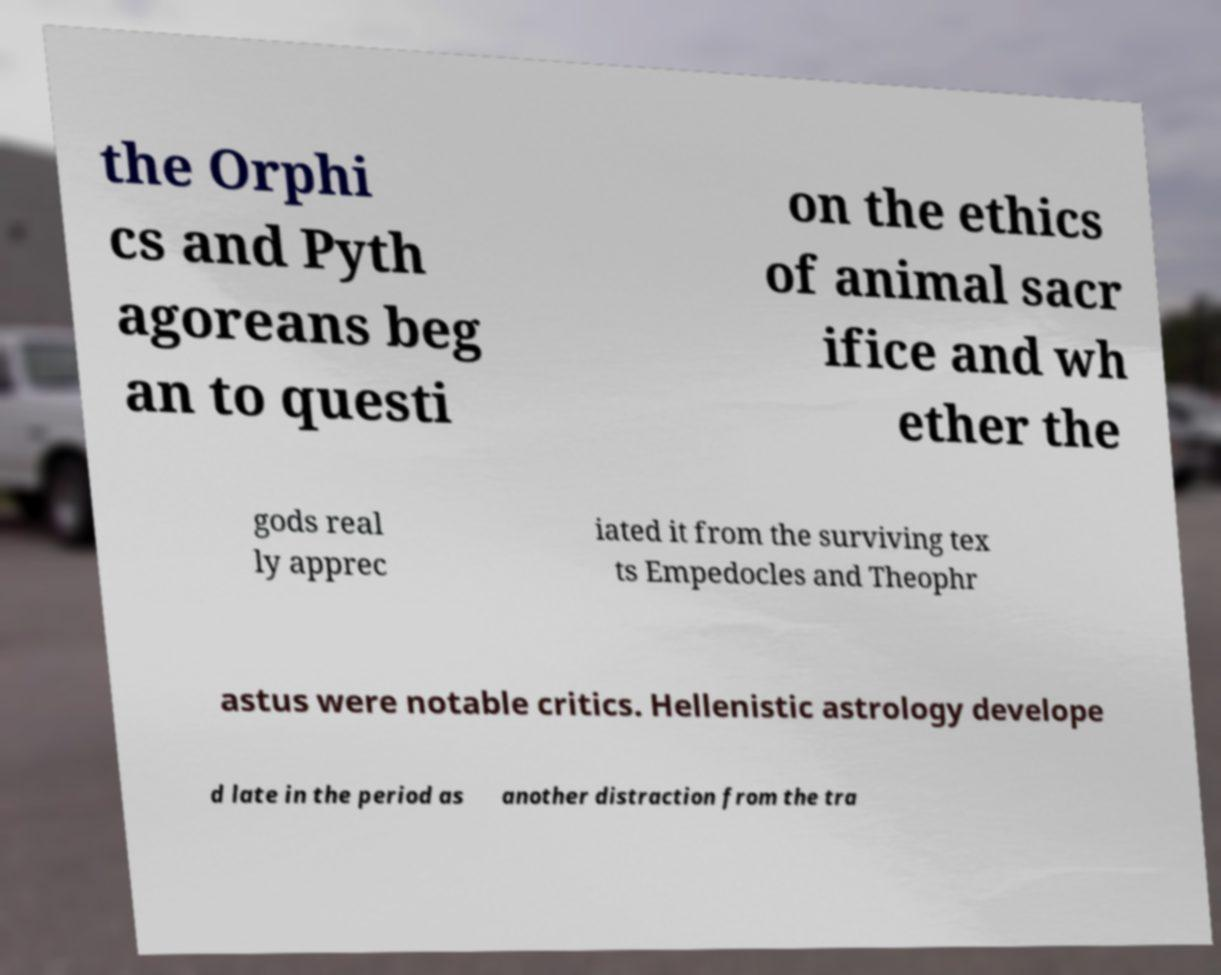What messages or text are displayed in this image? I need them in a readable, typed format. the Orphi cs and Pyth agoreans beg an to questi on the ethics of animal sacr ifice and wh ether the gods real ly apprec iated it from the surviving tex ts Empedocles and Theophr astus were notable critics. Hellenistic astrology develope d late in the period as another distraction from the tra 